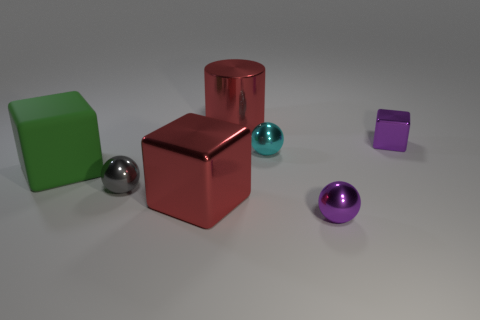Add 2 tiny cubes. How many objects exist? 9 Subtract all tiny cyan spheres. How many spheres are left? 2 Add 7 tiny cyan things. How many tiny cyan things are left? 8 Add 6 tiny green shiny balls. How many tiny green shiny balls exist? 6 Subtract all purple cubes. How many cubes are left? 2 Subtract 0 blue balls. How many objects are left? 7 Subtract all cylinders. How many objects are left? 6 Subtract 1 cylinders. How many cylinders are left? 0 Subtract all red blocks. Subtract all red cylinders. How many blocks are left? 2 Subtract all red cubes. How many purple balls are left? 1 